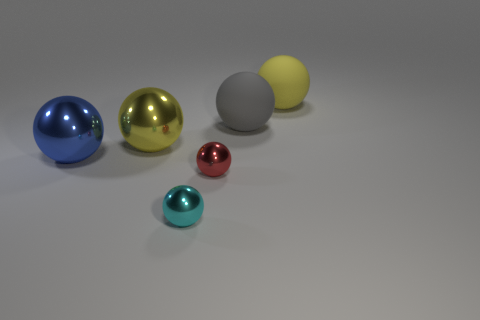What size is the red shiny thing?
Ensure brevity in your answer.  Small. There is a metallic ball that is behind the big ball that is in front of the yellow shiny thing; are there any gray balls that are on the left side of it?
Offer a terse response. No. There is a small red ball; how many blue spheres are right of it?
Provide a succinct answer. 0. What number of things are either metal objects that are behind the cyan metal ball or objects that are on the right side of the red ball?
Give a very brief answer. 5. Is the number of large blue shiny objects greater than the number of blue blocks?
Provide a succinct answer. Yes. What color is the metallic thing that is right of the tiny cyan shiny sphere?
Offer a very short reply. Red. Do the small red thing and the big yellow shiny thing have the same shape?
Provide a succinct answer. Yes. The large ball that is both on the right side of the big blue metal sphere and in front of the gray thing is what color?
Ensure brevity in your answer.  Yellow. Do the yellow thing behind the gray sphere and the blue shiny thing in front of the gray sphere have the same size?
Your answer should be compact. Yes. What number of things are either big shiny things right of the blue object or red objects?
Provide a short and direct response. 2. 